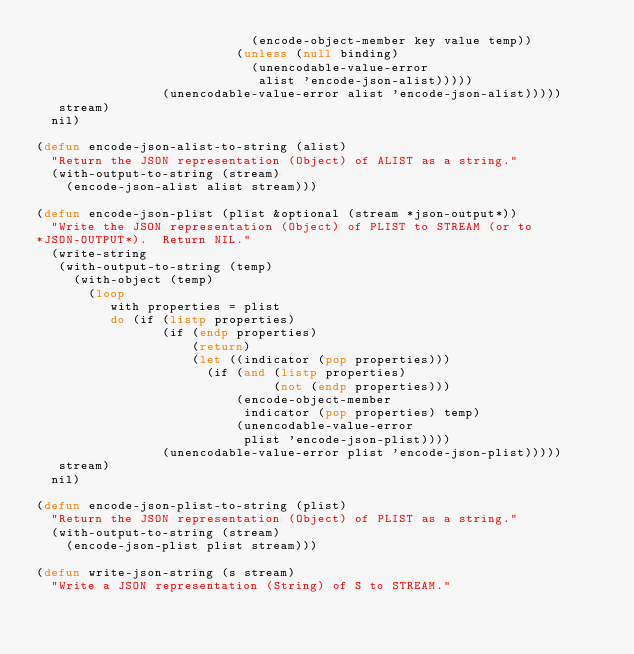Convert code to text. <code><loc_0><loc_0><loc_500><loc_500><_Lisp_>                             (encode-object-member key value temp))
                           (unless (null binding)
                             (unencodable-value-error
                              alist 'encode-json-alist)))))
                 (unencodable-value-error alist 'encode-json-alist)))))
   stream)
  nil)

(defun encode-json-alist-to-string (alist)
  "Return the JSON representation (Object) of ALIST as a string."
  (with-output-to-string (stream)
    (encode-json-alist alist stream)))

(defun encode-json-plist (plist &optional (stream *json-output*))
  "Write the JSON representation (Object) of PLIST to STREAM (or to
*JSON-OUTPUT*).  Return NIL."
  (write-string
   (with-output-to-string (temp)
     (with-object (temp)
       (loop
          with properties = plist
          do (if (listp properties)
                 (if (endp properties)
                     (return)
                     (let ((indicator (pop properties)))
                       (if (and (listp properties)
                                (not (endp properties)))
                           (encode-object-member
                            indicator (pop properties) temp)
                           (unencodable-value-error
                            plist 'encode-json-plist))))
                 (unencodable-value-error plist 'encode-json-plist)))))
   stream)
  nil)

(defun encode-json-plist-to-string (plist)
  "Return the JSON representation (Object) of PLIST as a string."
  (with-output-to-string (stream)
    (encode-json-plist plist stream)))

(defun write-json-string (s stream)
  "Write a JSON representation (String) of S to STREAM."</code> 